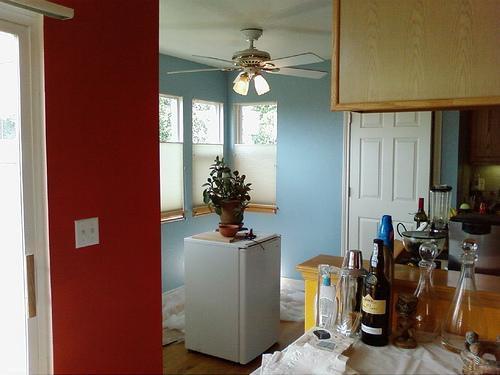How many plants are there?
Give a very brief answer. 1. How many refrigerators are in the photo?
Give a very brief answer. 1. 